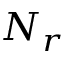Convert formula to latex. <formula><loc_0><loc_0><loc_500><loc_500>N _ { r }</formula> 